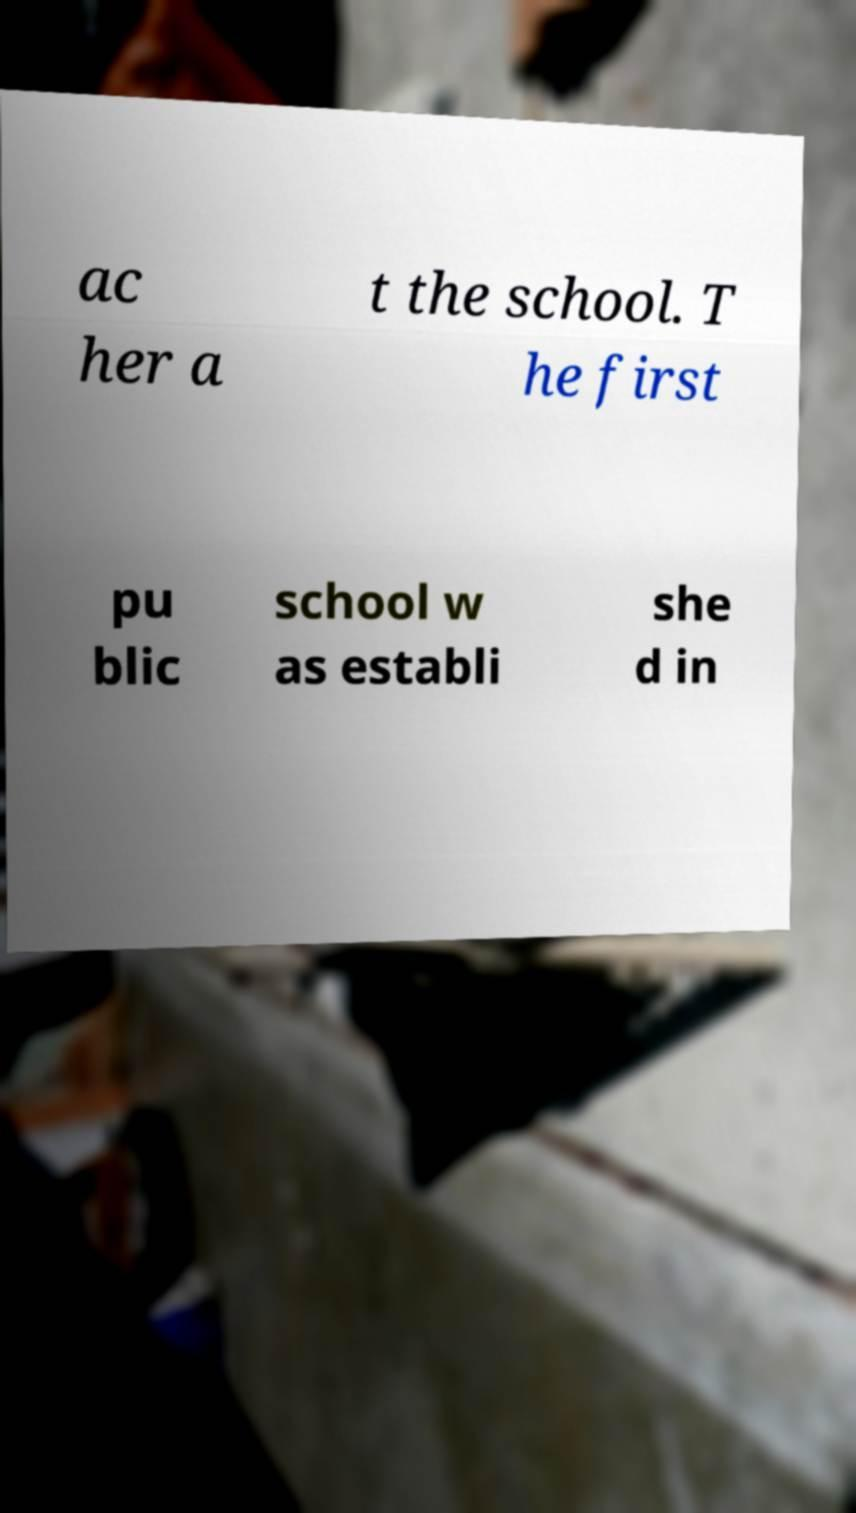Please read and relay the text visible in this image. What does it say? ac her a t the school. T he first pu blic school w as establi she d in 